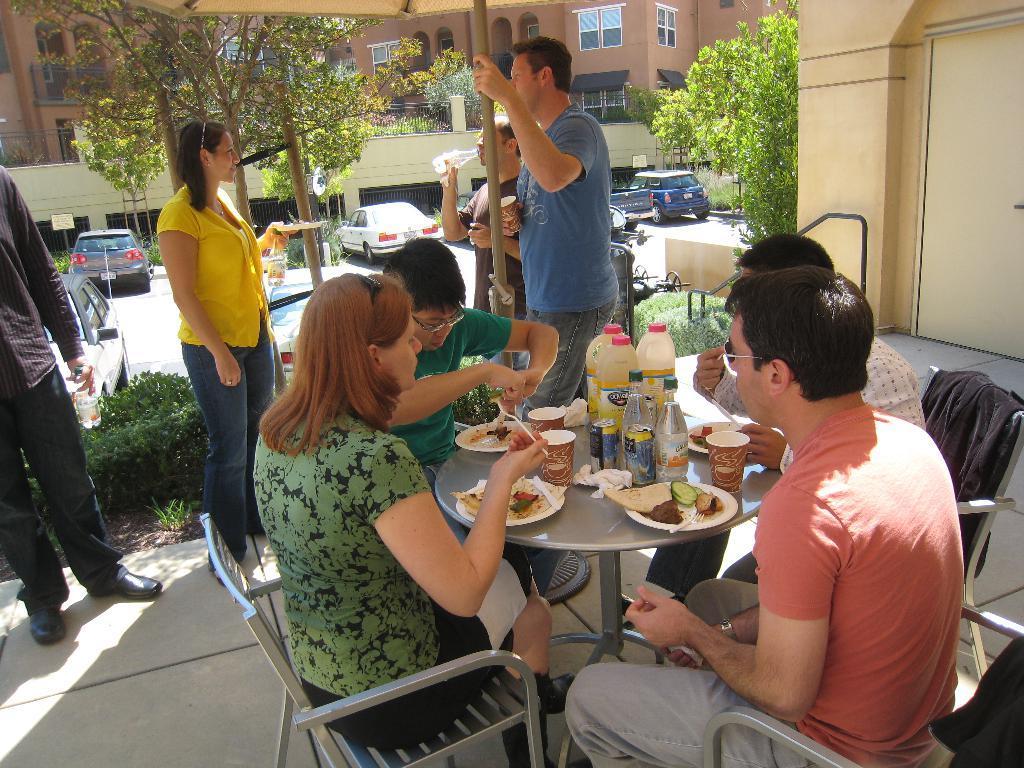In one or two sentences, can you explain what this image depicts? The picture is taken outside the building where there are four people sitting on the chairs and in front of them there is a round table on which food, glasses, bottles, tissues are placed and behind them there are four people standing. One man in blue shirt is holding a glass and holding a pole by his hand, another person is drinking water and one woman is standing in yellow t-shirt and jeans and behind them there are vehicles on the road and trees are present and there are buildings in brown colour. 